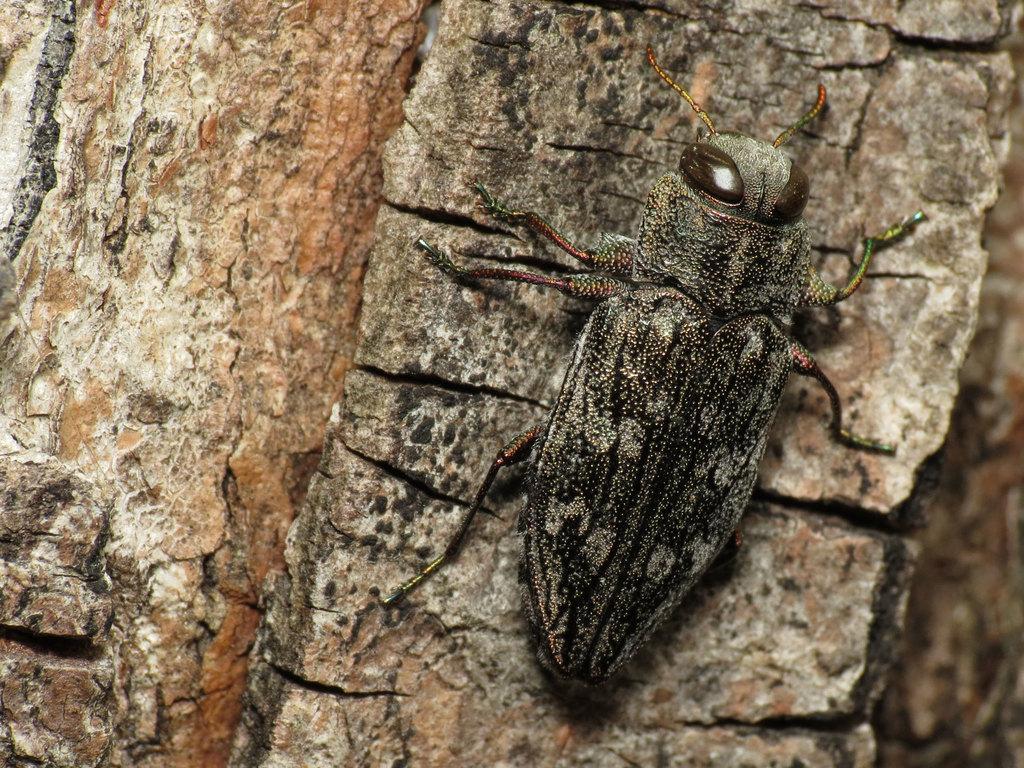Please provide a concise description of this image. In this image, we can see an insect which is attached to a wooden trunk. 